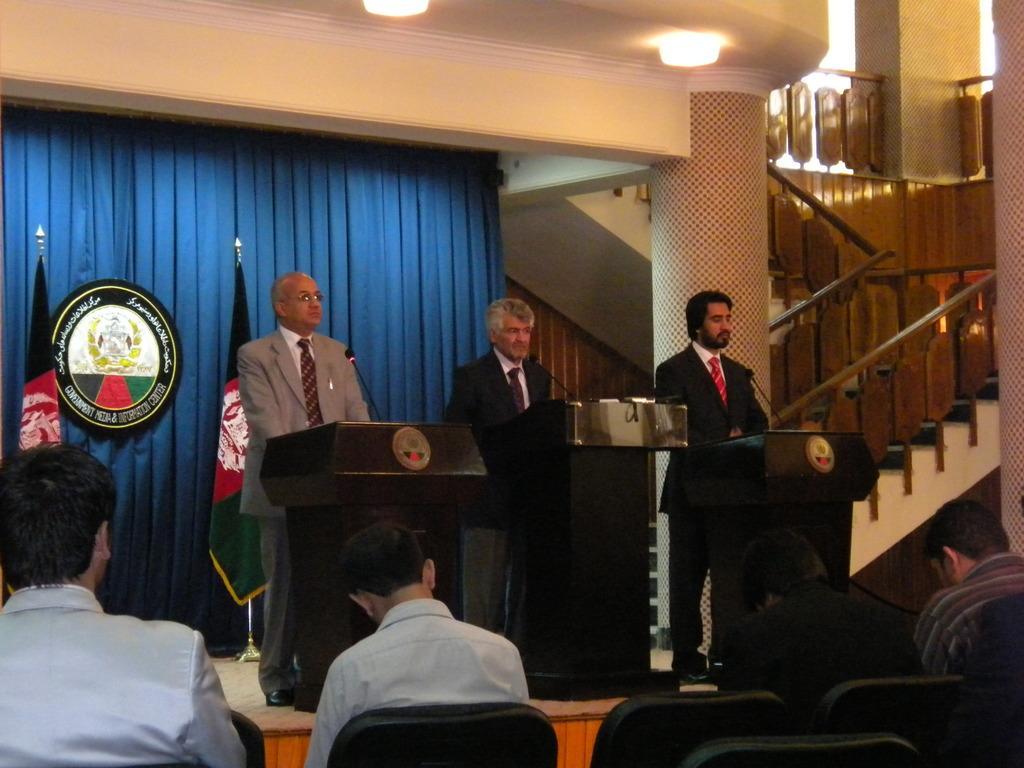Describe this image in one or two sentences. In this image I can see few chairs which are black in color and few persons are sitting on them. I can see the stage, few persons standing on the stage in front of the podiums, few flags, the blue colored curtain, a building, few stairs, the railing, a pillar and few lights. 